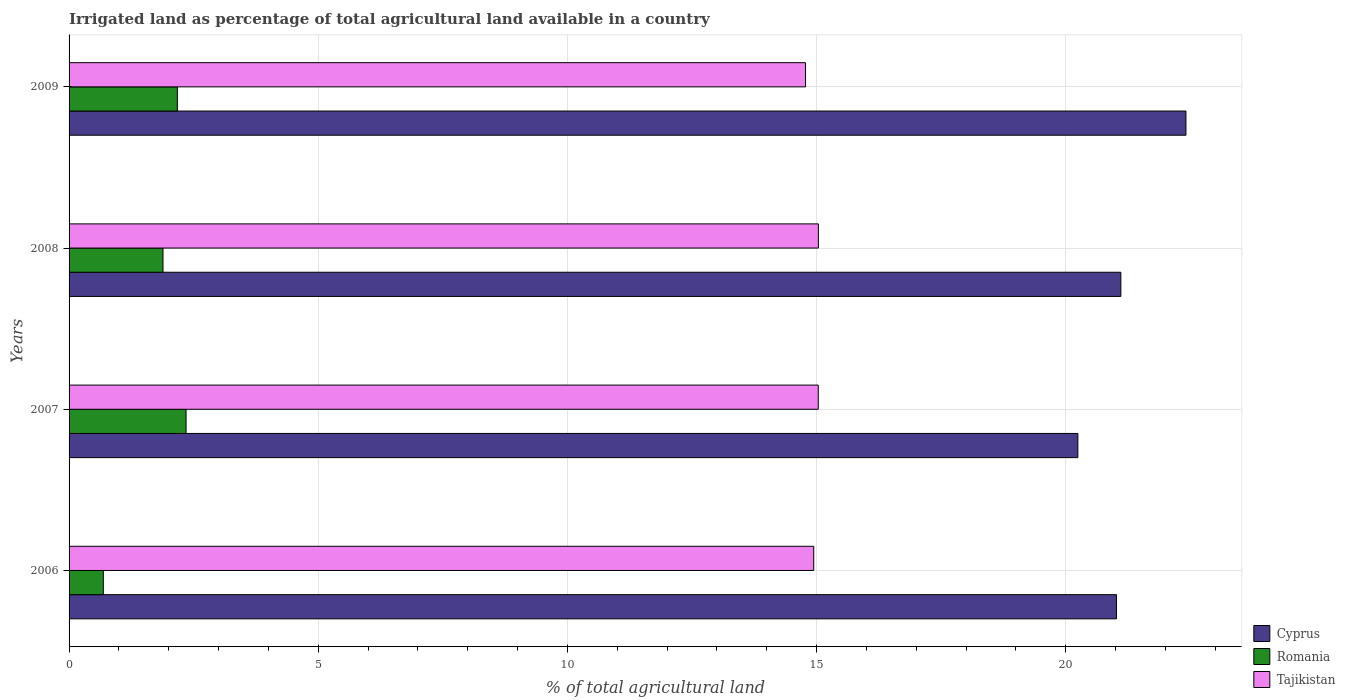Are the number of bars per tick equal to the number of legend labels?
Provide a succinct answer. Yes. How many bars are there on the 4th tick from the top?
Keep it short and to the point. 3. In how many cases, is the number of bars for a given year not equal to the number of legend labels?
Your answer should be very brief. 0. What is the percentage of irrigated land in Romania in 2009?
Offer a terse response. 2.17. Across all years, what is the maximum percentage of irrigated land in Cyprus?
Offer a terse response. 22.41. Across all years, what is the minimum percentage of irrigated land in Romania?
Your response must be concise. 0.69. What is the total percentage of irrigated land in Tajikistan in the graph?
Offer a terse response. 59.79. What is the difference between the percentage of irrigated land in Romania in 2006 and that in 2009?
Provide a short and direct response. -1.49. What is the difference between the percentage of irrigated land in Cyprus in 2006 and the percentage of irrigated land in Tajikistan in 2008?
Offer a very short reply. 5.98. What is the average percentage of irrigated land in Cyprus per year?
Your answer should be compact. 21.2. In the year 2006, what is the difference between the percentage of irrigated land in Cyprus and percentage of irrigated land in Tajikistan?
Your answer should be compact. 6.08. What is the ratio of the percentage of irrigated land in Cyprus in 2007 to that in 2008?
Ensure brevity in your answer.  0.96. What is the difference between the highest and the second highest percentage of irrigated land in Cyprus?
Your response must be concise. 1.31. What is the difference between the highest and the lowest percentage of irrigated land in Romania?
Provide a short and direct response. 1.66. Is the sum of the percentage of irrigated land in Cyprus in 2006 and 2009 greater than the maximum percentage of irrigated land in Tajikistan across all years?
Make the answer very short. Yes. What does the 2nd bar from the top in 2008 represents?
Offer a terse response. Romania. What does the 3rd bar from the bottom in 2009 represents?
Your response must be concise. Tajikistan. How many bars are there?
Provide a short and direct response. 12. Are all the bars in the graph horizontal?
Your response must be concise. Yes. How many years are there in the graph?
Provide a succinct answer. 4. What is the difference between two consecutive major ticks on the X-axis?
Your response must be concise. 5. Does the graph contain grids?
Your answer should be very brief. Yes. How many legend labels are there?
Keep it short and to the point. 3. How are the legend labels stacked?
Ensure brevity in your answer.  Vertical. What is the title of the graph?
Offer a terse response. Irrigated land as percentage of total agricultural land available in a country. Does "Mongolia" appear as one of the legend labels in the graph?
Your answer should be compact. No. What is the label or title of the X-axis?
Provide a succinct answer. % of total agricultural land. What is the label or title of the Y-axis?
Give a very brief answer. Years. What is the % of total agricultural land of Cyprus in 2006?
Keep it short and to the point. 21.02. What is the % of total agricultural land of Romania in 2006?
Offer a very short reply. 0.69. What is the % of total agricultural land in Tajikistan in 2006?
Provide a succinct answer. 14.94. What is the % of total agricultural land of Cyprus in 2007?
Ensure brevity in your answer.  20.24. What is the % of total agricultural land in Romania in 2007?
Keep it short and to the point. 2.35. What is the % of total agricultural land of Tajikistan in 2007?
Your response must be concise. 15.03. What is the % of total agricultural land of Cyprus in 2008?
Provide a short and direct response. 21.11. What is the % of total agricultural land of Romania in 2008?
Your answer should be compact. 1.88. What is the % of total agricultural land of Tajikistan in 2008?
Give a very brief answer. 15.04. What is the % of total agricultural land of Cyprus in 2009?
Ensure brevity in your answer.  22.41. What is the % of total agricultural land in Romania in 2009?
Provide a succinct answer. 2.17. What is the % of total agricultural land in Tajikistan in 2009?
Provide a short and direct response. 14.78. Across all years, what is the maximum % of total agricultural land in Cyprus?
Offer a terse response. 22.41. Across all years, what is the maximum % of total agricultural land in Romania?
Give a very brief answer. 2.35. Across all years, what is the maximum % of total agricultural land in Tajikistan?
Your response must be concise. 15.04. Across all years, what is the minimum % of total agricultural land of Cyprus?
Keep it short and to the point. 20.24. Across all years, what is the minimum % of total agricultural land in Romania?
Keep it short and to the point. 0.69. Across all years, what is the minimum % of total agricultural land of Tajikistan?
Offer a terse response. 14.78. What is the total % of total agricultural land in Cyprus in the graph?
Make the answer very short. 84.78. What is the total % of total agricultural land of Romania in the graph?
Ensure brevity in your answer.  7.09. What is the total % of total agricultural land in Tajikistan in the graph?
Keep it short and to the point. 59.79. What is the difference between the % of total agricultural land in Cyprus in 2006 and that in 2007?
Your response must be concise. 0.77. What is the difference between the % of total agricultural land in Romania in 2006 and that in 2007?
Offer a terse response. -1.66. What is the difference between the % of total agricultural land of Tajikistan in 2006 and that in 2007?
Give a very brief answer. -0.09. What is the difference between the % of total agricultural land in Cyprus in 2006 and that in 2008?
Your answer should be very brief. -0.09. What is the difference between the % of total agricultural land of Romania in 2006 and that in 2008?
Your answer should be very brief. -1.2. What is the difference between the % of total agricultural land of Tajikistan in 2006 and that in 2008?
Give a very brief answer. -0.09. What is the difference between the % of total agricultural land of Cyprus in 2006 and that in 2009?
Your answer should be very brief. -1.39. What is the difference between the % of total agricultural land of Romania in 2006 and that in 2009?
Make the answer very short. -1.49. What is the difference between the % of total agricultural land in Tajikistan in 2006 and that in 2009?
Ensure brevity in your answer.  0.17. What is the difference between the % of total agricultural land of Cyprus in 2007 and that in 2008?
Keep it short and to the point. -0.86. What is the difference between the % of total agricultural land in Romania in 2007 and that in 2008?
Provide a succinct answer. 0.46. What is the difference between the % of total agricultural land of Tajikistan in 2007 and that in 2008?
Provide a succinct answer. -0. What is the difference between the % of total agricultural land in Cyprus in 2007 and that in 2009?
Your answer should be very brief. -2.17. What is the difference between the % of total agricultural land in Romania in 2007 and that in 2009?
Keep it short and to the point. 0.17. What is the difference between the % of total agricultural land in Tajikistan in 2007 and that in 2009?
Offer a very short reply. 0.26. What is the difference between the % of total agricultural land of Cyprus in 2008 and that in 2009?
Provide a short and direct response. -1.31. What is the difference between the % of total agricultural land in Romania in 2008 and that in 2009?
Provide a succinct answer. -0.29. What is the difference between the % of total agricultural land of Tajikistan in 2008 and that in 2009?
Offer a very short reply. 0.26. What is the difference between the % of total agricultural land in Cyprus in 2006 and the % of total agricultural land in Romania in 2007?
Provide a short and direct response. 18.67. What is the difference between the % of total agricultural land of Cyprus in 2006 and the % of total agricultural land of Tajikistan in 2007?
Offer a terse response. 5.98. What is the difference between the % of total agricultural land in Romania in 2006 and the % of total agricultural land in Tajikistan in 2007?
Ensure brevity in your answer.  -14.35. What is the difference between the % of total agricultural land in Cyprus in 2006 and the % of total agricultural land in Romania in 2008?
Offer a terse response. 19.13. What is the difference between the % of total agricultural land in Cyprus in 2006 and the % of total agricultural land in Tajikistan in 2008?
Give a very brief answer. 5.98. What is the difference between the % of total agricultural land in Romania in 2006 and the % of total agricultural land in Tajikistan in 2008?
Ensure brevity in your answer.  -14.35. What is the difference between the % of total agricultural land of Cyprus in 2006 and the % of total agricultural land of Romania in 2009?
Offer a terse response. 18.85. What is the difference between the % of total agricultural land in Cyprus in 2006 and the % of total agricultural land in Tajikistan in 2009?
Provide a short and direct response. 6.24. What is the difference between the % of total agricultural land in Romania in 2006 and the % of total agricultural land in Tajikistan in 2009?
Provide a short and direct response. -14.09. What is the difference between the % of total agricultural land of Cyprus in 2007 and the % of total agricultural land of Romania in 2008?
Make the answer very short. 18.36. What is the difference between the % of total agricultural land of Cyprus in 2007 and the % of total agricultural land of Tajikistan in 2008?
Keep it short and to the point. 5.21. What is the difference between the % of total agricultural land in Romania in 2007 and the % of total agricultural land in Tajikistan in 2008?
Give a very brief answer. -12.69. What is the difference between the % of total agricultural land in Cyprus in 2007 and the % of total agricultural land in Romania in 2009?
Your response must be concise. 18.07. What is the difference between the % of total agricultural land of Cyprus in 2007 and the % of total agricultural land of Tajikistan in 2009?
Your response must be concise. 5.47. What is the difference between the % of total agricultural land in Romania in 2007 and the % of total agricultural land in Tajikistan in 2009?
Offer a terse response. -12.43. What is the difference between the % of total agricultural land in Cyprus in 2008 and the % of total agricultural land in Romania in 2009?
Keep it short and to the point. 18.93. What is the difference between the % of total agricultural land of Cyprus in 2008 and the % of total agricultural land of Tajikistan in 2009?
Provide a short and direct response. 6.33. What is the difference between the % of total agricultural land of Romania in 2008 and the % of total agricultural land of Tajikistan in 2009?
Ensure brevity in your answer.  -12.89. What is the average % of total agricultural land of Cyprus per year?
Your response must be concise. 21.2. What is the average % of total agricultural land in Romania per year?
Make the answer very short. 1.77. What is the average % of total agricultural land of Tajikistan per year?
Offer a very short reply. 14.95. In the year 2006, what is the difference between the % of total agricultural land of Cyprus and % of total agricultural land of Romania?
Ensure brevity in your answer.  20.33. In the year 2006, what is the difference between the % of total agricultural land in Cyprus and % of total agricultural land in Tajikistan?
Ensure brevity in your answer.  6.08. In the year 2006, what is the difference between the % of total agricultural land of Romania and % of total agricultural land of Tajikistan?
Your answer should be very brief. -14.26. In the year 2007, what is the difference between the % of total agricultural land in Cyprus and % of total agricultural land in Romania?
Offer a very short reply. 17.9. In the year 2007, what is the difference between the % of total agricultural land of Cyprus and % of total agricultural land of Tajikistan?
Your answer should be very brief. 5.21. In the year 2007, what is the difference between the % of total agricultural land of Romania and % of total agricultural land of Tajikistan?
Offer a very short reply. -12.69. In the year 2008, what is the difference between the % of total agricultural land in Cyprus and % of total agricultural land in Romania?
Keep it short and to the point. 19.22. In the year 2008, what is the difference between the % of total agricultural land of Cyprus and % of total agricultural land of Tajikistan?
Ensure brevity in your answer.  6.07. In the year 2008, what is the difference between the % of total agricultural land of Romania and % of total agricultural land of Tajikistan?
Keep it short and to the point. -13.15. In the year 2009, what is the difference between the % of total agricultural land of Cyprus and % of total agricultural land of Romania?
Make the answer very short. 20.24. In the year 2009, what is the difference between the % of total agricultural land in Cyprus and % of total agricultural land in Tajikistan?
Your answer should be very brief. 7.63. In the year 2009, what is the difference between the % of total agricultural land in Romania and % of total agricultural land in Tajikistan?
Offer a very short reply. -12.61. What is the ratio of the % of total agricultural land in Cyprus in 2006 to that in 2007?
Provide a short and direct response. 1.04. What is the ratio of the % of total agricultural land of Romania in 2006 to that in 2007?
Offer a very short reply. 0.29. What is the ratio of the % of total agricultural land of Romania in 2006 to that in 2008?
Provide a short and direct response. 0.36. What is the ratio of the % of total agricultural land in Cyprus in 2006 to that in 2009?
Your answer should be compact. 0.94. What is the ratio of the % of total agricultural land of Romania in 2006 to that in 2009?
Your answer should be compact. 0.32. What is the ratio of the % of total agricultural land of Tajikistan in 2006 to that in 2009?
Keep it short and to the point. 1.01. What is the ratio of the % of total agricultural land of Cyprus in 2007 to that in 2008?
Ensure brevity in your answer.  0.96. What is the ratio of the % of total agricultural land of Romania in 2007 to that in 2008?
Provide a short and direct response. 1.25. What is the ratio of the % of total agricultural land in Tajikistan in 2007 to that in 2008?
Provide a succinct answer. 1. What is the ratio of the % of total agricultural land in Cyprus in 2007 to that in 2009?
Give a very brief answer. 0.9. What is the ratio of the % of total agricultural land of Romania in 2007 to that in 2009?
Give a very brief answer. 1.08. What is the ratio of the % of total agricultural land of Tajikistan in 2007 to that in 2009?
Keep it short and to the point. 1.02. What is the ratio of the % of total agricultural land in Cyprus in 2008 to that in 2009?
Your response must be concise. 0.94. What is the ratio of the % of total agricultural land in Romania in 2008 to that in 2009?
Provide a short and direct response. 0.87. What is the ratio of the % of total agricultural land in Tajikistan in 2008 to that in 2009?
Your answer should be compact. 1.02. What is the difference between the highest and the second highest % of total agricultural land of Cyprus?
Your answer should be very brief. 1.31. What is the difference between the highest and the second highest % of total agricultural land in Romania?
Provide a succinct answer. 0.17. What is the difference between the highest and the second highest % of total agricultural land of Tajikistan?
Your response must be concise. 0. What is the difference between the highest and the lowest % of total agricultural land of Cyprus?
Make the answer very short. 2.17. What is the difference between the highest and the lowest % of total agricultural land of Romania?
Make the answer very short. 1.66. What is the difference between the highest and the lowest % of total agricultural land in Tajikistan?
Give a very brief answer. 0.26. 